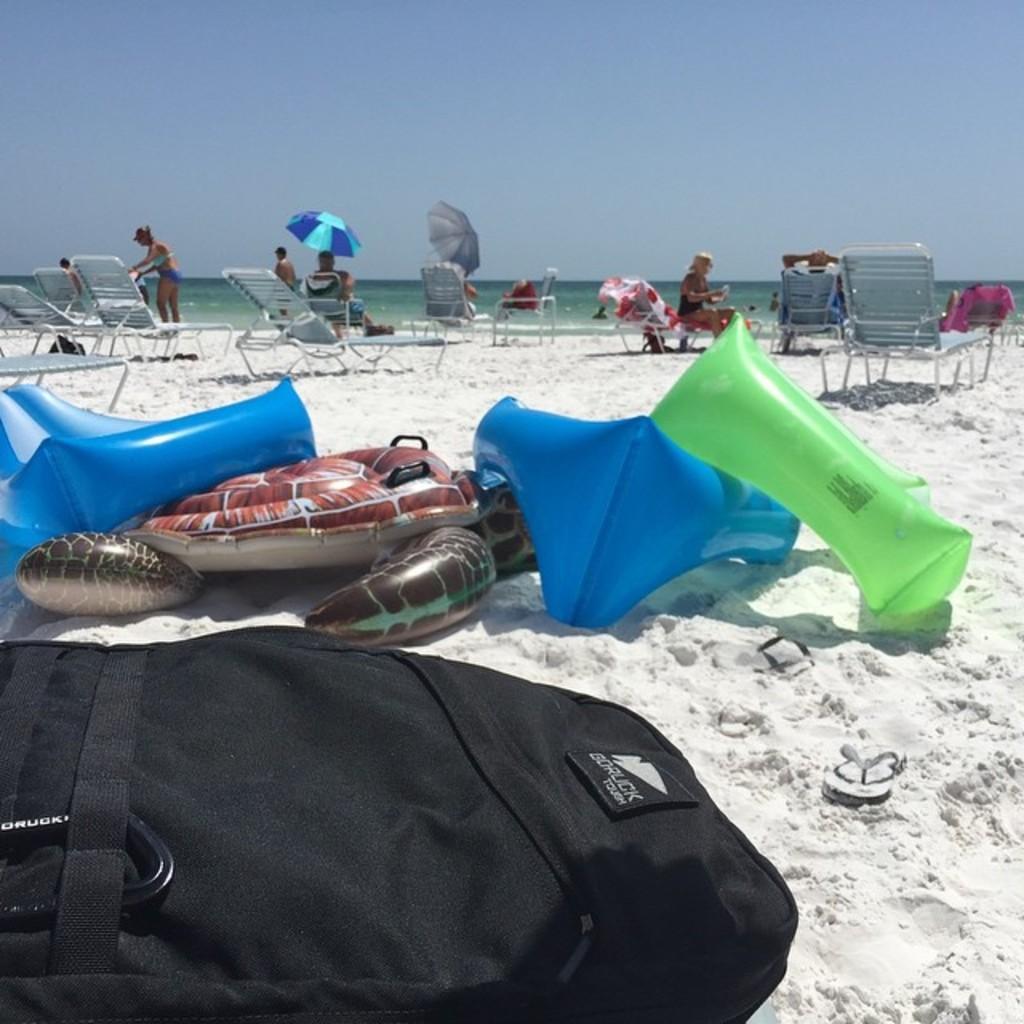Could you give a brief overview of what you see in this image? In this image there are some objects are kept as we can see in the bottom of this image. there are some chairs and persons in middle of this image. there is a sky on the top of this image. 